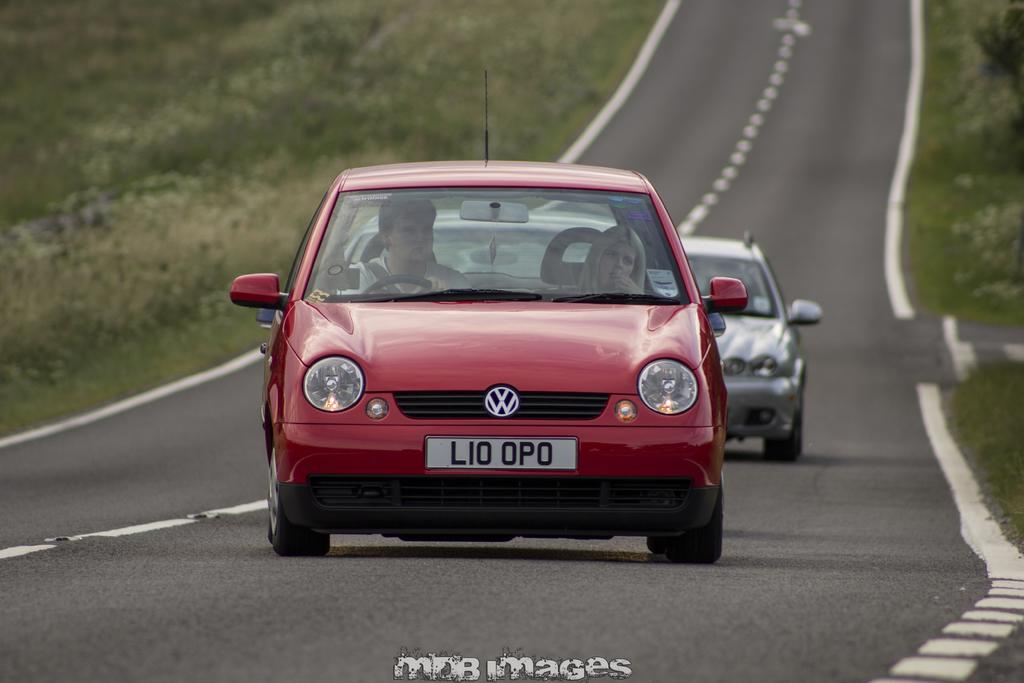How many cars are in the image? There are two cars in the image. What color is the car in the front? The car in the front is red. Is there anyone inside the red car? Yes, there is a person sitting in the red car. What color is the car in the background? The car in the background is white. What type of natural environment can be seen in the image? There is grass visible in the image, and there are also plants present. Is there a trick performed by the person sitting in the red car in the image? There is no trick being performed by the person sitting in the red car in the image. Are there any police officers visible in the image? There is no mention of police officers in the image, so we cannot determine if any are present. 